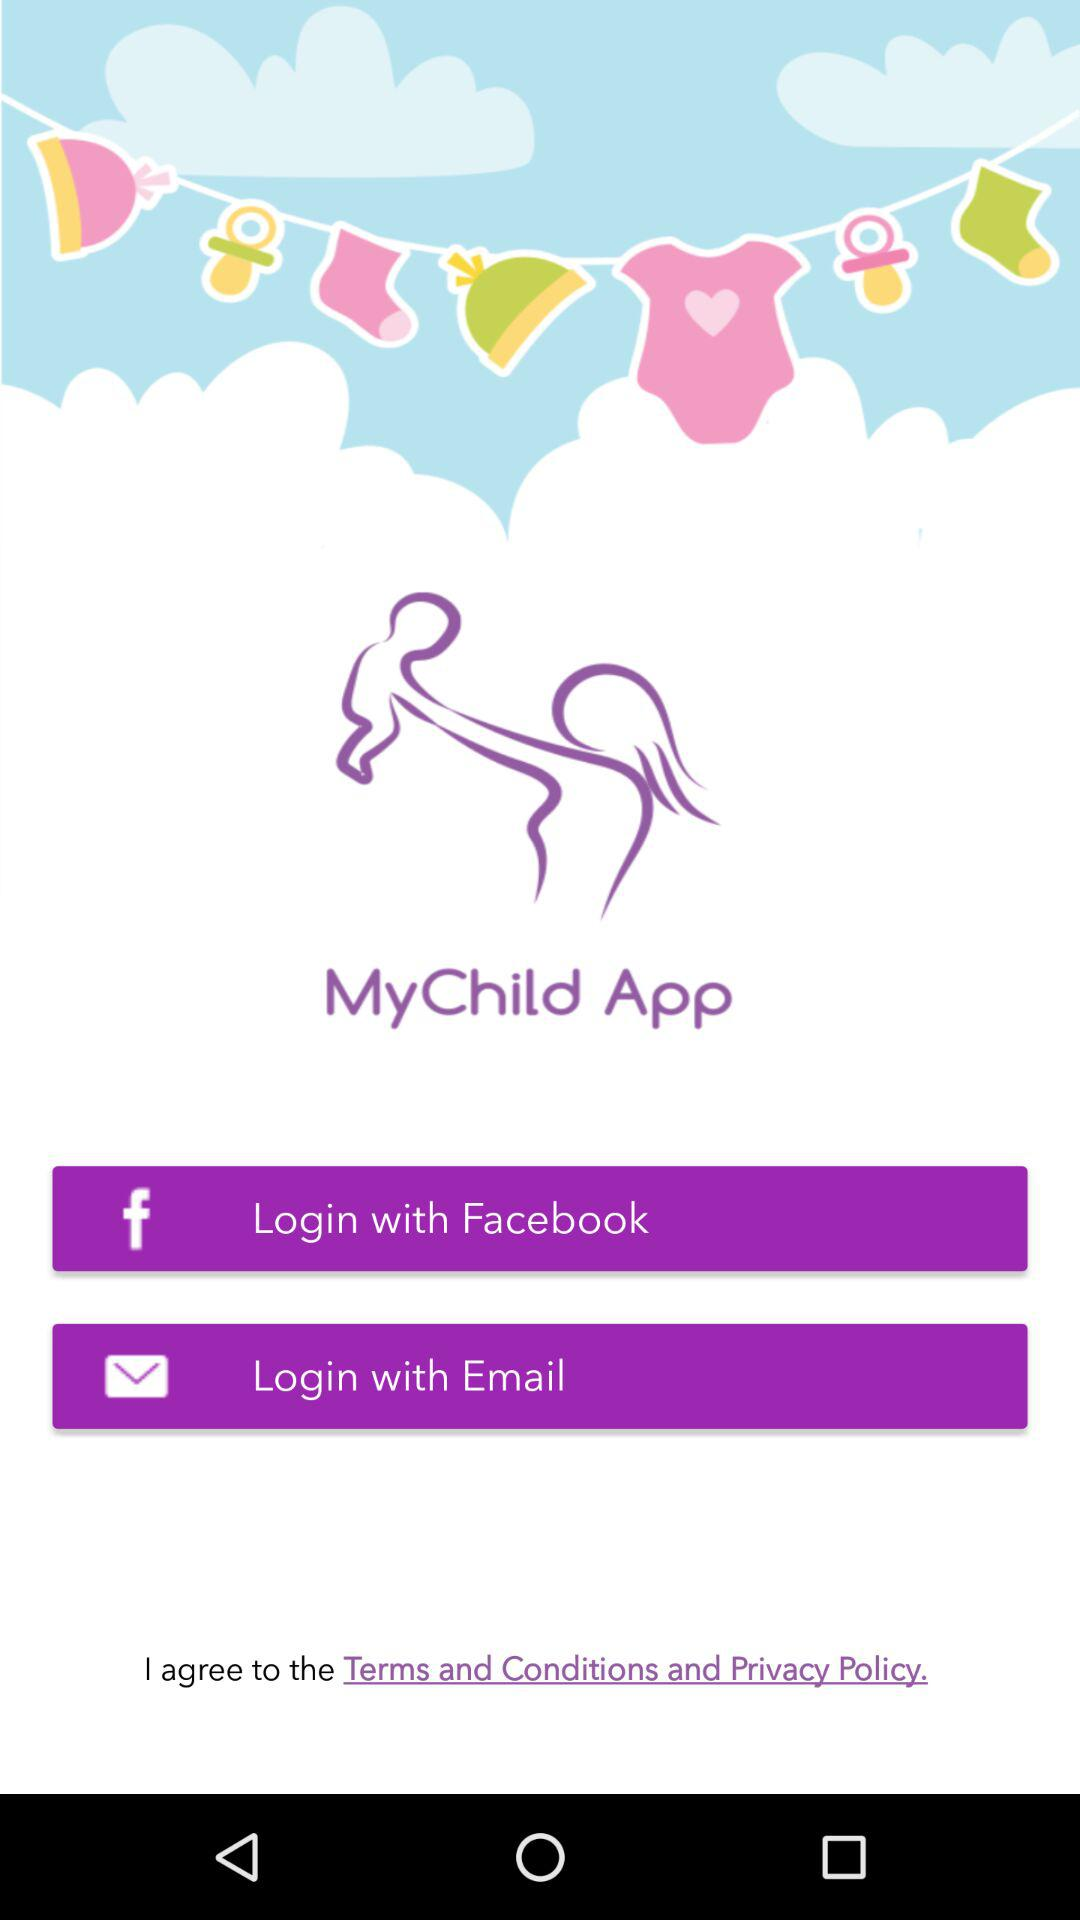With what app can we log in? You can log in with "Facebook". 